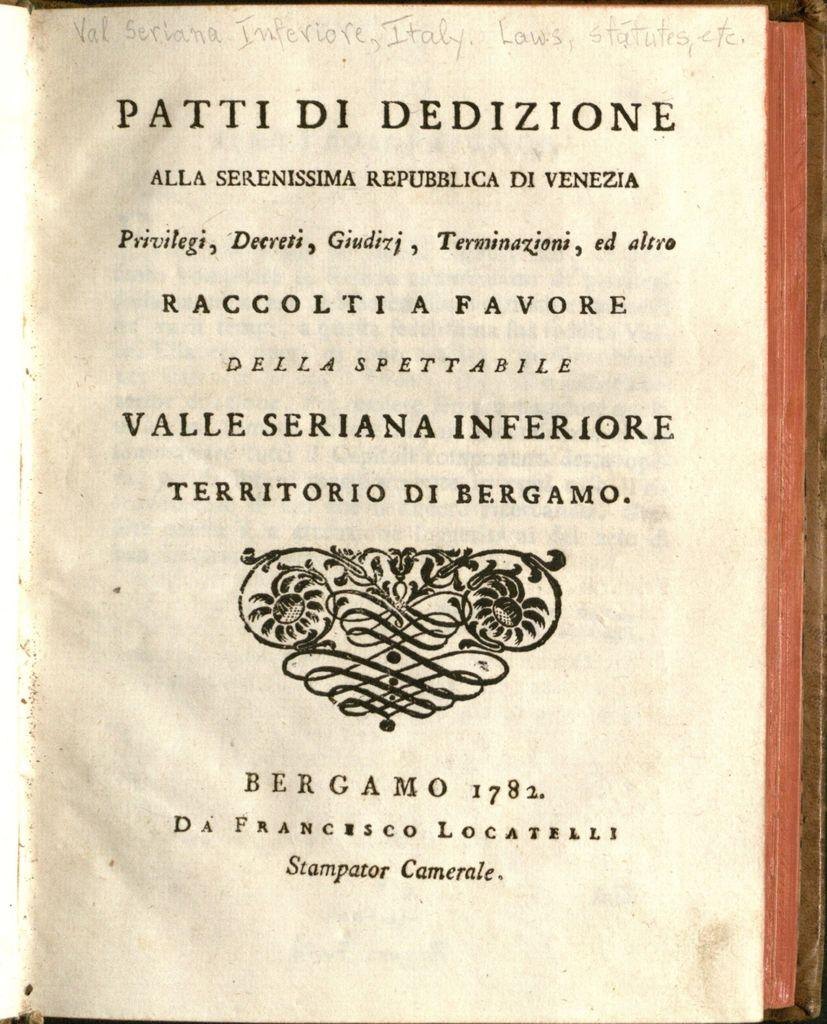Provide a one-sentence caption for the provided image. The cover of a book bearing many Italian words has been marked by a pencil indicating that the book is about laws and statutes. 